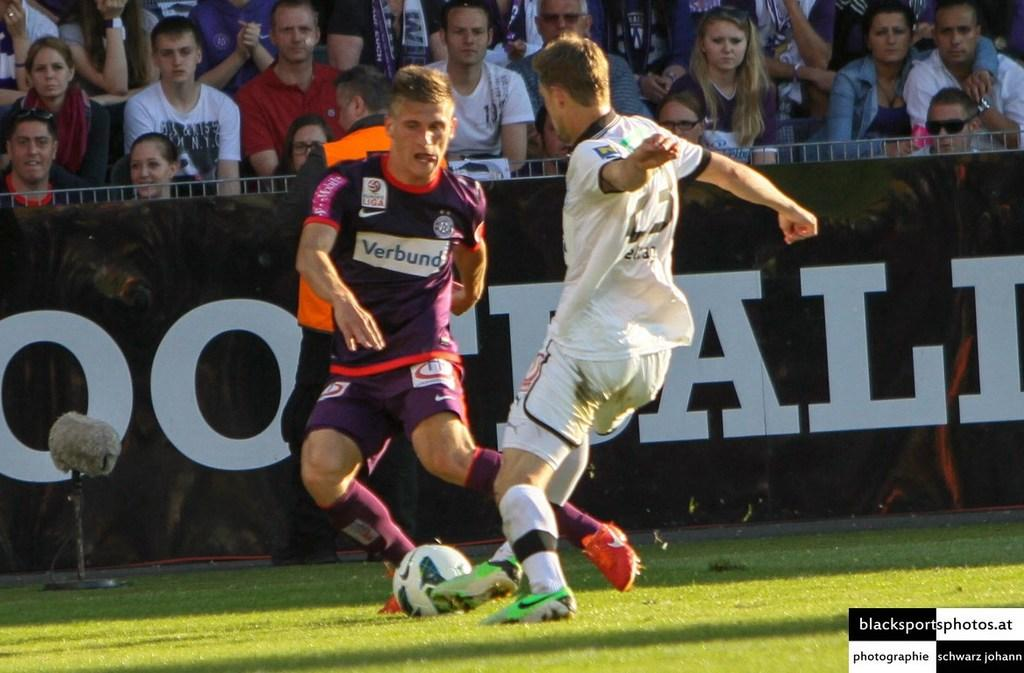Provide a one-sentence caption for the provided image. The shot of the two footballers vying for the soccer ball was supplied by blacksportsphotos.at. 